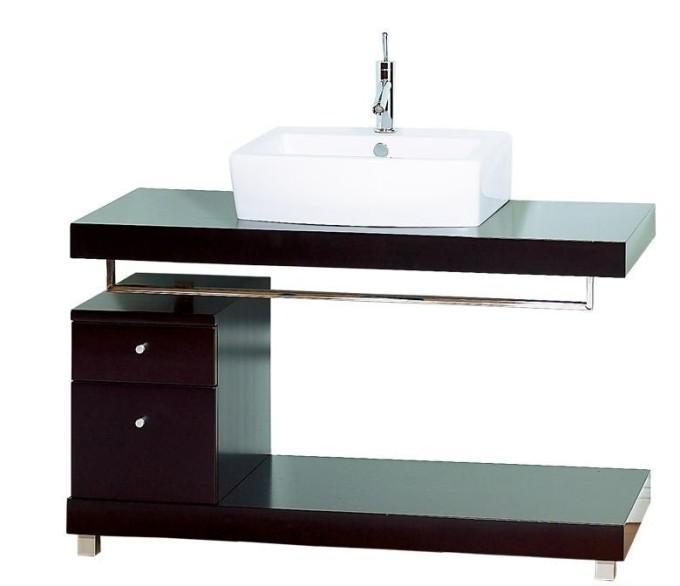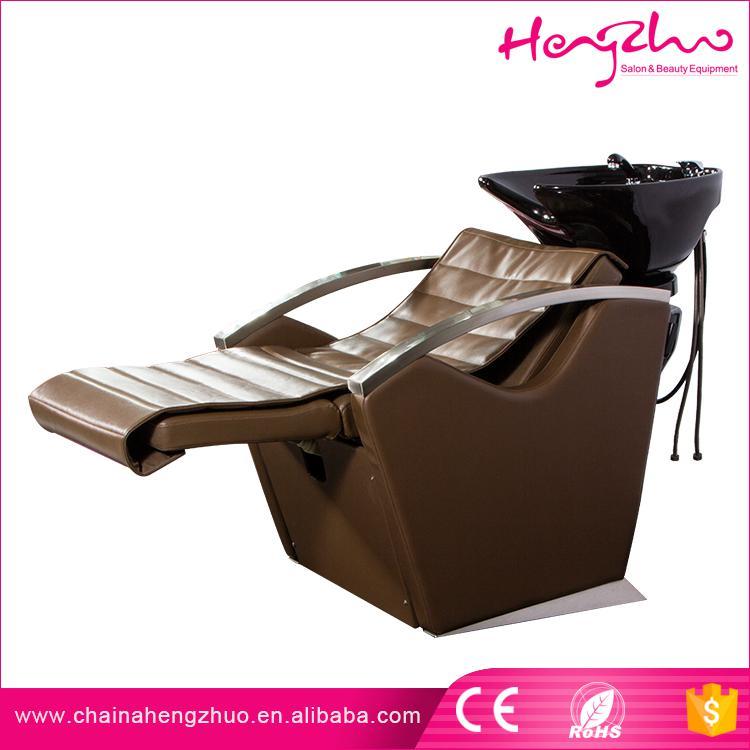The first image is the image on the left, the second image is the image on the right. Considering the images on both sides, is "The right image features a reclined chair positioned under a small sink." valid? Answer yes or no. Yes. The first image is the image on the left, the second image is the image on the right. Evaluate the accuracy of this statement regarding the images: "One of the images features two sinks.". Is it true? Answer yes or no. No. 